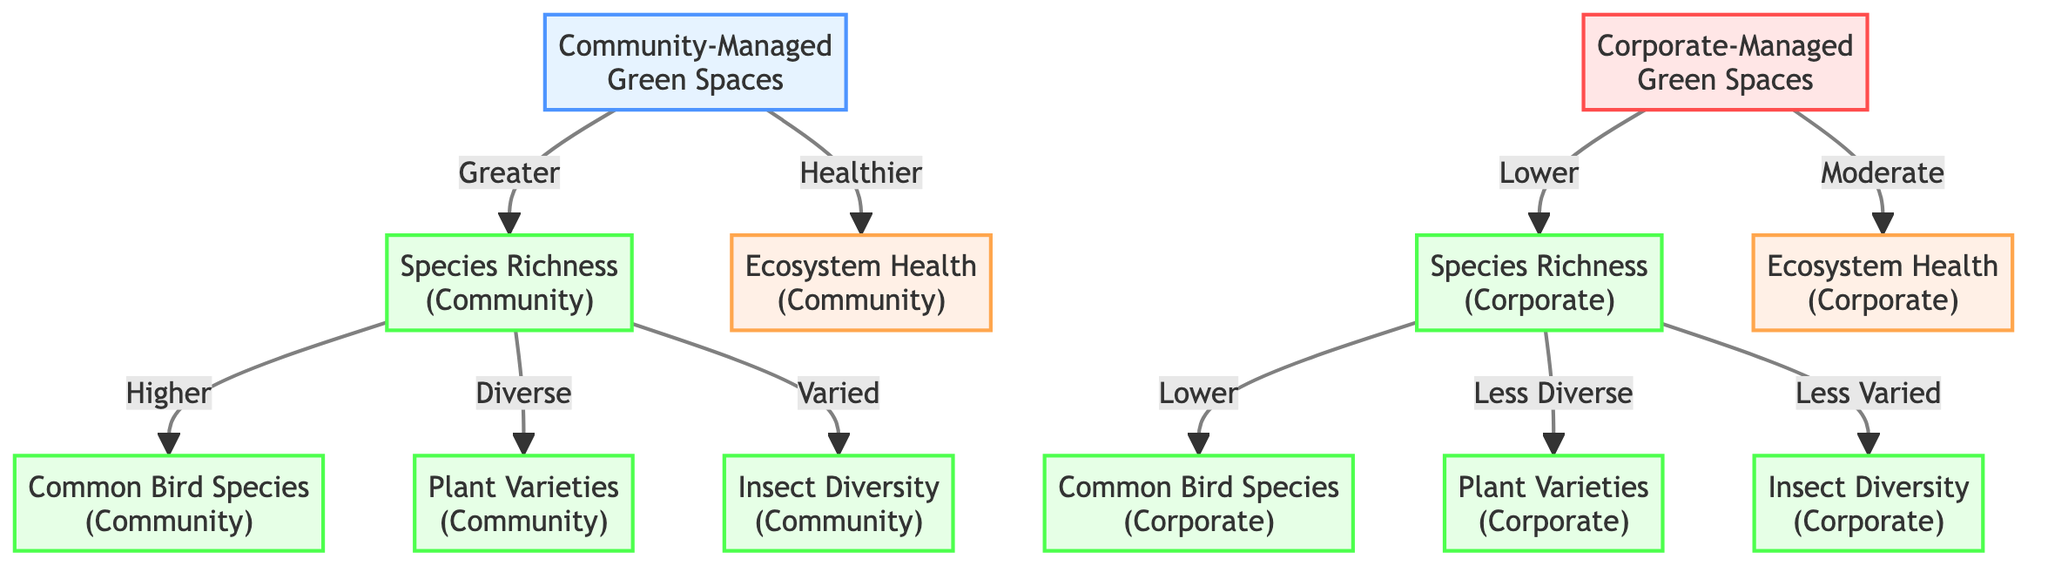What is the type of management for the green spaces with greater species richness? The diagram shows that community-managed green spaces are linked to greater species richness, indicated by the arrow pointing from community_management to species_richness_community.
Answer: Community-Managed What is the health level of corporate-managed ecosystems? The diagram indicates the health level of ecosystems managed by corporations is labeled as "Moderate," as shown by the connection from corporate_management to ecosystem_health_corporate.
Answer: Moderate How many types of species richness are listed for community-managed spaces? The diagram reveals three species categories—Common Bird Species, Plant Varieties, and Insect Diversity—each connected to species_richness_community. Counting these confirms there are three types.
Answer: Three Which type of management leads to healthier ecosystems? The diagram clearly indicates that ecosystems managed by the community have a designation as "Healthier," compared to the corporate-managed ones, which have less health as signified by the connection to ecosystem_health_corporate.
Answer: Community What type of insect diversity is found in corporate-managed ecosystems? According to the flow from species_richness_corporate, corporate-managed ecosystems are linked to "Less Varied" insect diversity, as described in the diagram.
Answer: Less Varied Which species category is associated with corporate-managed green spaces? The connections show that corporate-managed green spaces are connected to "Common Bird Species," "Less Diverse" plant varieties, and "Less Varied" insect diversity. Since the question asks for one category, "Common Bird Species" is a valid answer per the diagram.
Answer: Common Bird Species What does the arrow from community management to ecosystem health indicate? The arrow from community_management to ecosystem_health_community signifies that community management results in a healthier ecosystem, based on the directional relationship represented.
Answer: Healthier What are the descriptors used for species richness in corporate-managed settings? In the diagram, species richness in corporate-managed settings is mentioned as "Lower," which directly connects to species_richness_corporate and reflects the state described in the chart.
Answer: Lower 